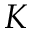<formula> <loc_0><loc_0><loc_500><loc_500>K</formula> 